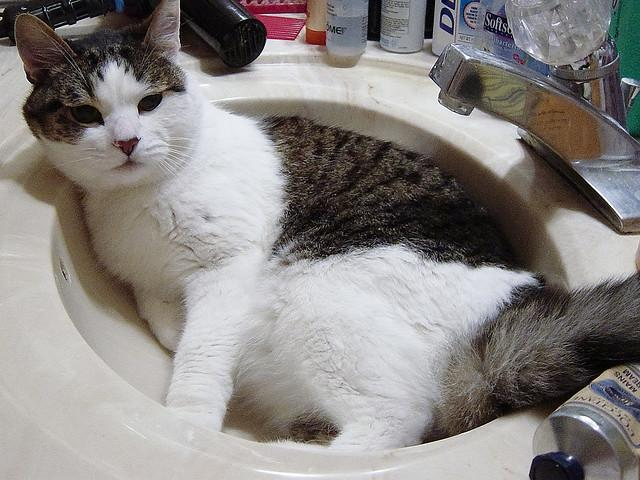Why is the cat in the sink? resting 